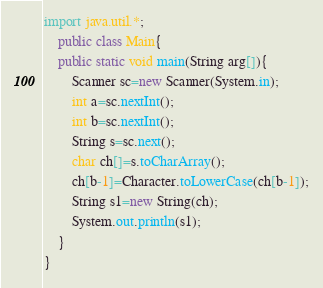<code> <loc_0><loc_0><loc_500><loc_500><_Java_>import java.util.*;
    public class Main{ 
    public static void main(String arg[]){
		Scanner sc=new Scanner(System.in);
		int a=sc.nextInt();
		int b=sc.nextInt();
		String s=sc.next();
		char ch[]=s.toCharArray();
		ch[b-1]=Character.toLowerCase(ch[b-1]);
		String s1=new String(ch);
		System.out.println(s1);
	}
}</code> 